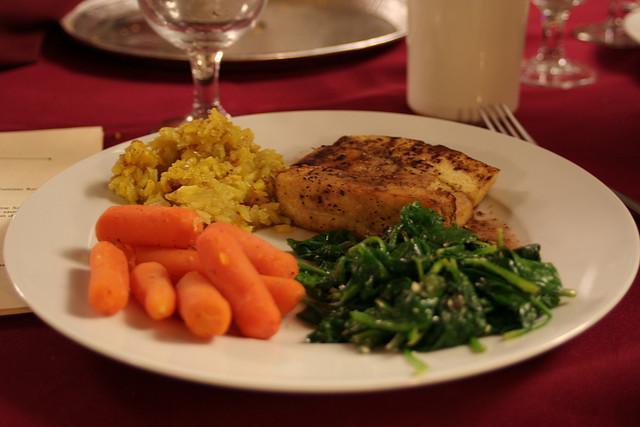How many varieties of vegetables are there?
Give a very brief answer. 2. How many pancakes are there?
Give a very brief answer. 0. How many wine glasses are there?
Give a very brief answer. 2. How many carrots are visible?
Give a very brief answer. 5. 